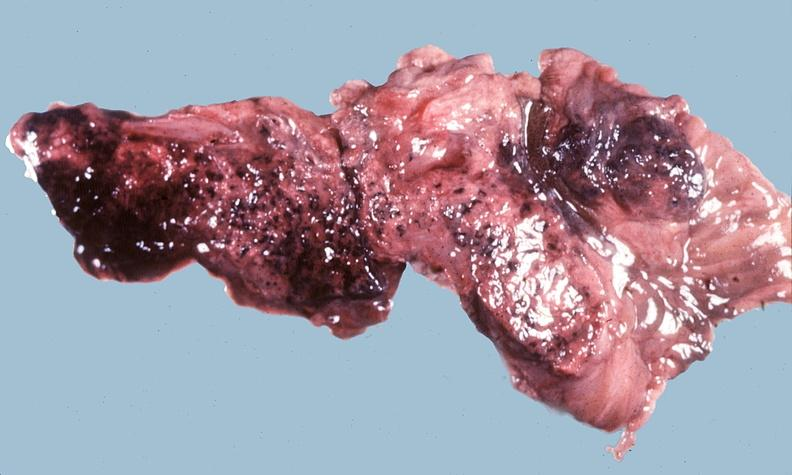what does this image show?
Answer the question using a single word or phrase. Acute hemorrhagic pancreatitis 